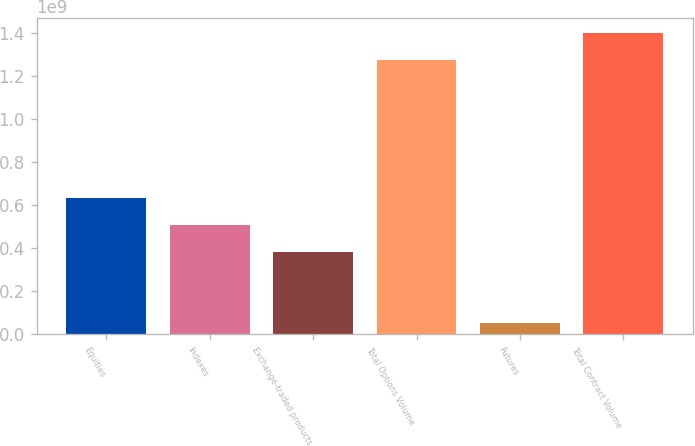<chart> <loc_0><loc_0><loc_500><loc_500><bar_chart><fcel>Equities<fcel>Indexes<fcel>Exchange-traded products<fcel>Total Options Volume<fcel>Futures<fcel>Total Contract Volume<nl><fcel>6.34698e+08<fcel>5.0722e+08<fcel>3.79742e+08<fcel>1.27478e+09<fcel>5.06154e+07<fcel>1.40226e+09<nl></chart> 